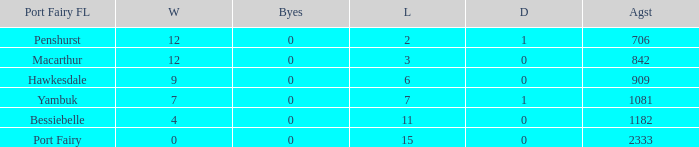How many draws when the Port Fairy FL is Hawkesdale and there are more than 9 wins? None. 